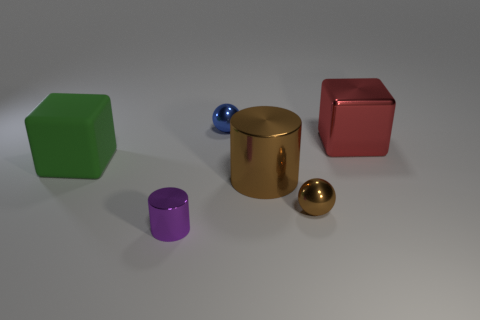Is there anything else that has the same color as the rubber object?
Make the answer very short. No. What shape is the large green object?
Your answer should be very brief. Cube. There is another sphere that is the same material as the blue ball; what is its color?
Keep it short and to the point. Brown. Is the number of purple objects greater than the number of purple spheres?
Provide a succinct answer. Yes. Is there a large red object?
Provide a short and direct response. Yes. What shape is the shiny thing left of the metal thing behind the large shiny cube?
Offer a very short reply. Cylinder. How many objects are either large red cubes or small balls that are behind the green object?
Your answer should be very brief. 2. There is a ball that is in front of the small ball that is behind the ball in front of the green matte object; what is its color?
Your response must be concise. Brown. There is another object that is the same shape as the tiny brown metal object; what material is it?
Your answer should be very brief. Metal. What is the color of the rubber thing?
Provide a succinct answer. Green. 